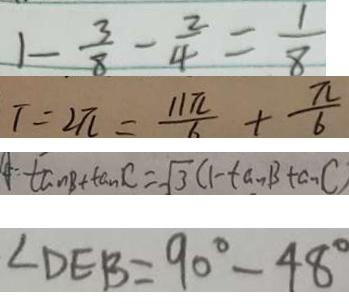<formula> <loc_0><loc_0><loc_500><loc_500>1 - \frac { 3 } { 8 } - \frac { 2 } { 4 } = \frac { 1 } { 8 } 
 T = 2 \pi = \frac { 1 1 \pi } { 6 } + \frac { \pi } { 6 } 
 \tan B + \tan C = \sqrt { 3 } ( 1 - \tan B \tan C ) 
 \angle D E B = 9 0 ^ { \circ } - 4 8 ^ { \circ }</formula> 